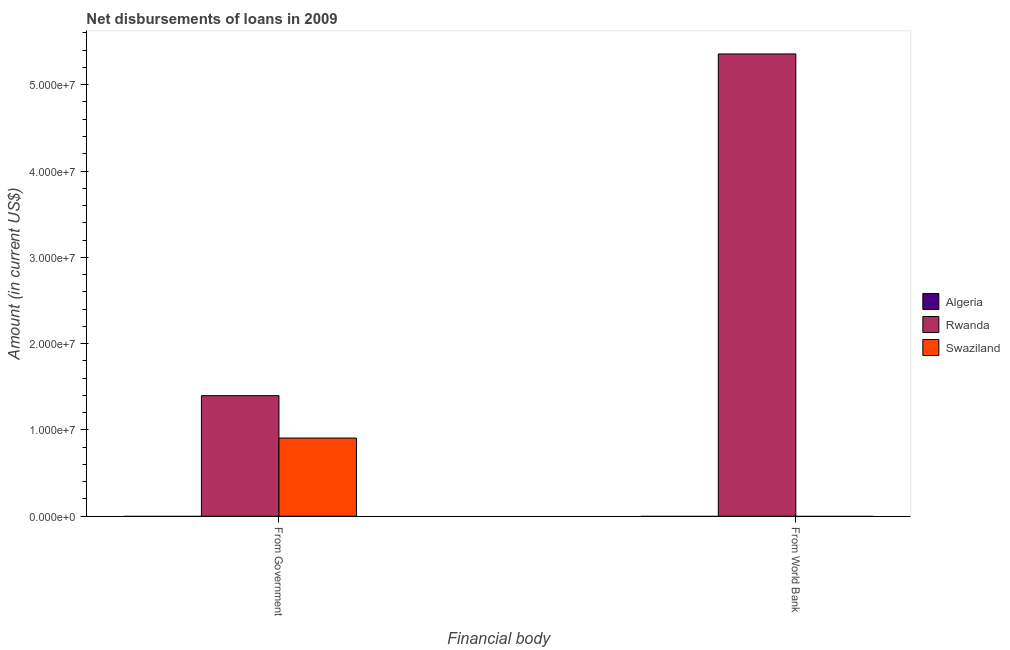How many different coloured bars are there?
Make the answer very short. 2. How many bars are there on the 2nd tick from the left?
Give a very brief answer. 1. What is the label of the 2nd group of bars from the left?
Give a very brief answer. From World Bank. Across all countries, what is the maximum net disbursements of loan from government?
Your response must be concise. 1.40e+07. Across all countries, what is the minimum net disbursements of loan from world bank?
Offer a terse response. 0. In which country was the net disbursements of loan from world bank maximum?
Ensure brevity in your answer.  Rwanda. What is the total net disbursements of loan from world bank in the graph?
Ensure brevity in your answer.  5.36e+07. What is the difference between the net disbursements of loan from government in Rwanda and that in Swaziland?
Offer a very short reply. 4.91e+06. What is the difference between the net disbursements of loan from government in Rwanda and the net disbursements of loan from world bank in Swaziland?
Offer a very short reply. 1.40e+07. What is the average net disbursements of loan from world bank per country?
Provide a short and direct response. 1.79e+07. What is the difference between the net disbursements of loan from world bank and net disbursements of loan from government in Rwanda?
Your response must be concise. 3.96e+07. In how many countries, is the net disbursements of loan from world bank greater than 22000000 US$?
Give a very brief answer. 1. What is the ratio of the net disbursements of loan from government in Swaziland to that in Rwanda?
Your response must be concise. 0.65. In how many countries, is the net disbursements of loan from world bank greater than the average net disbursements of loan from world bank taken over all countries?
Make the answer very short. 1. How many bars are there?
Offer a terse response. 3. Are all the bars in the graph horizontal?
Ensure brevity in your answer.  No. How many countries are there in the graph?
Provide a short and direct response. 3. Does the graph contain any zero values?
Offer a very short reply. Yes. Does the graph contain grids?
Your answer should be compact. No. Where does the legend appear in the graph?
Your response must be concise. Center right. How many legend labels are there?
Offer a very short reply. 3. How are the legend labels stacked?
Offer a terse response. Vertical. What is the title of the graph?
Keep it short and to the point. Net disbursements of loans in 2009. What is the label or title of the X-axis?
Provide a succinct answer. Financial body. What is the label or title of the Y-axis?
Provide a short and direct response. Amount (in current US$). What is the Amount (in current US$) in Rwanda in From Government?
Offer a very short reply. 1.40e+07. What is the Amount (in current US$) of Swaziland in From Government?
Provide a short and direct response. 9.06e+06. What is the Amount (in current US$) of Rwanda in From World Bank?
Your response must be concise. 5.36e+07. Across all Financial body, what is the maximum Amount (in current US$) in Rwanda?
Give a very brief answer. 5.36e+07. Across all Financial body, what is the maximum Amount (in current US$) of Swaziland?
Provide a succinct answer. 9.06e+06. Across all Financial body, what is the minimum Amount (in current US$) of Rwanda?
Offer a terse response. 1.40e+07. Across all Financial body, what is the minimum Amount (in current US$) in Swaziland?
Your answer should be compact. 0. What is the total Amount (in current US$) of Rwanda in the graph?
Make the answer very short. 6.75e+07. What is the total Amount (in current US$) of Swaziland in the graph?
Your response must be concise. 9.06e+06. What is the difference between the Amount (in current US$) in Rwanda in From Government and that in From World Bank?
Offer a terse response. -3.96e+07. What is the average Amount (in current US$) in Rwanda per Financial body?
Offer a very short reply. 3.38e+07. What is the average Amount (in current US$) in Swaziland per Financial body?
Your answer should be very brief. 4.53e+06. What is the difference between the Amount (in current US$) of Rwanda and Amount (in current US$) of Swaziland in From Government?
Your answer should be very brief. 4.91e+06. What is the ratio of the Amount (in current US$) in Rwanda in From Government to that in From World Bank?
Provide a succinct answer. 0.26. What is the difference between the highest and the second highest Amount (in current US$) of Rwanda?
Ensure brevity in your answer.  3.96e+07. What is the difference between the highest and the lowest Amount (in current US$) in Rwanda?
Give a very brief answer. 3.96e+07. What is the difference between the highest and the lowest Amount (in current US$) of Swaziland?
Make the answer very short. 9.06e+06. 